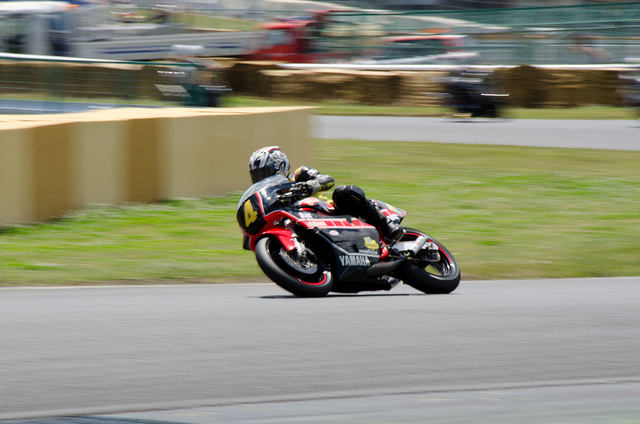Identify the text contained in this image. 4 YAMAHA 